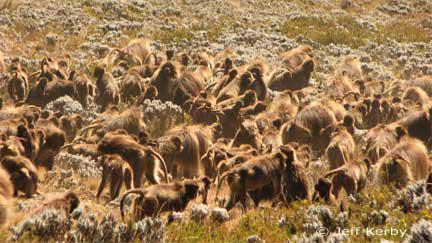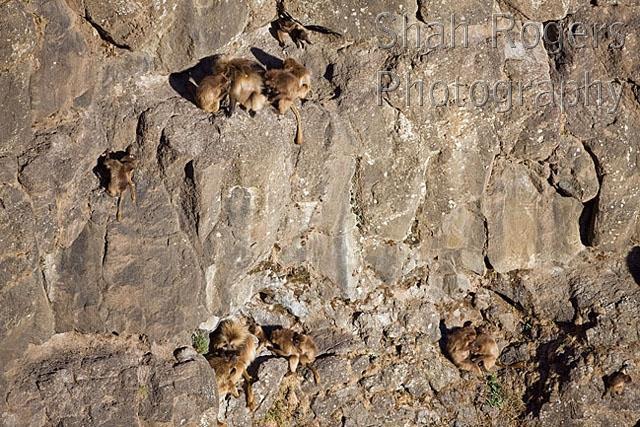The first image is the image on the left, the second image is the image on the right. For the images shown, is this caption "A red fox-like animal is standing in a scene near some monkeys." true? Answer yes or no. No. The first image is the image on the left, the second image is the image on the right. For the images displayed, is the sentence "A single wild dog sits in the wild with the primates." factually correct? Answer yes or no. No. 